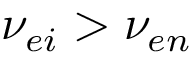Convert formula to latex. <formula><loc_0><loc_0><loc_500><loc_500>\nu _ { e i } > \nu _ { e n }</formula> 